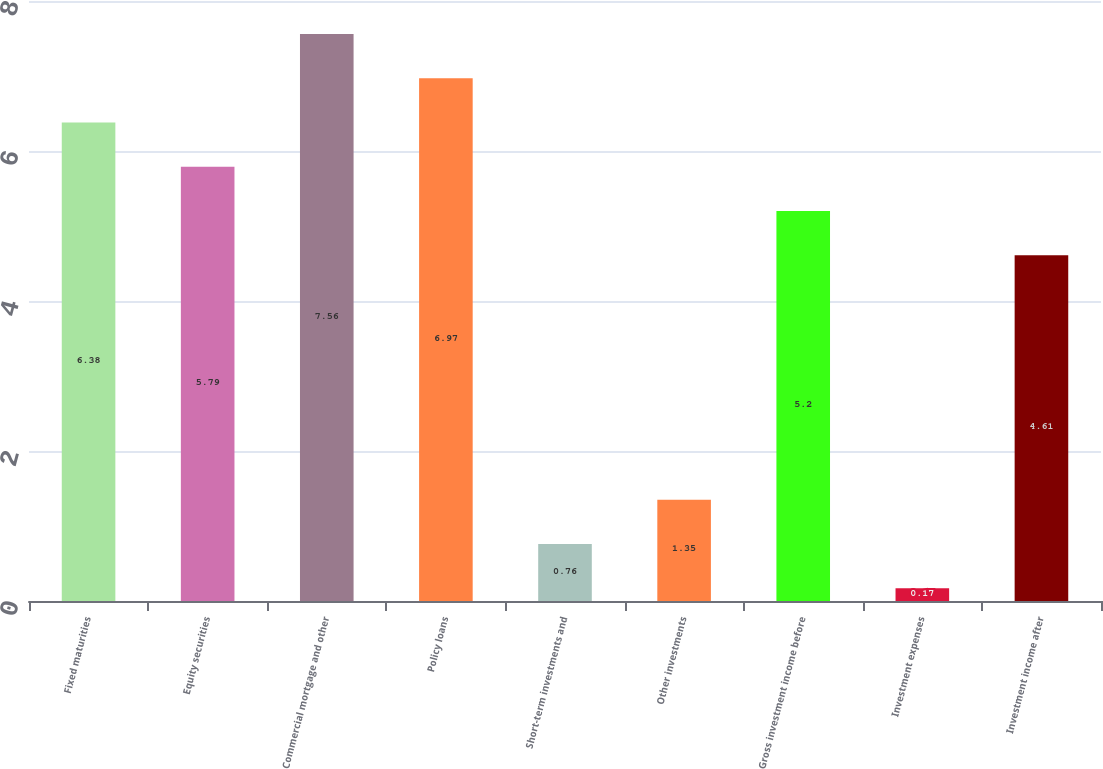<chart> <loc_0><loc_0><loc_500><loc_500><bar_chart><fcel>Fixed maturities<fcel>Equity securities<fcel>Commercial mortgage and other<fcel>Policy loans<fcel>Short-term investments and<fcel>Other investments<fcel>Gross investment income before<fcel>Investment expenses<fcel>Investment income after<nl><fcel>6.38<fcel>5.79<fcel>7.56<fcel>6.97<fcel>0.76<fcel>1.35<fcel>5.2<fcel>0.17<fcel>4.61<nl></chart> 